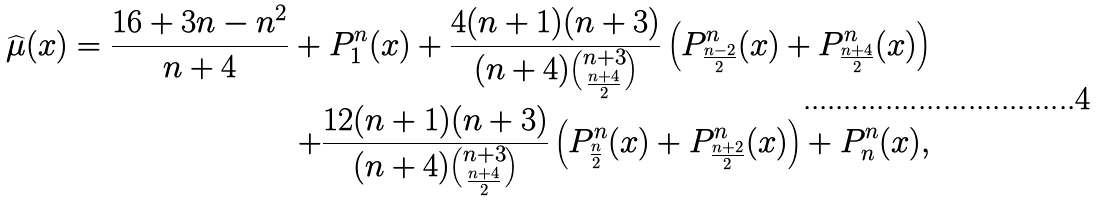Convert formula to latex. <formula><loc_0><loc_0><loc_500><loc_500>\widehat { \mu } ( x ) = \frac { 1 6 + 3 n - n ^ { 2 } } { n + 4 } + P _ { 1 } ^ { n } ( x ) + \frac { 4 ( n + 1 ) ( n + 3 ) } { ( n + 4 ) \binom { n + 3 } { \frac { n + 4 } { 2 } } } \left ( P _ { \frac { n - 2 } { 2 } } ^ { n } ( x ) + P _ { \frac { n + 4 } { 2 } } ^ { n } ( x ) \right ) \\ + \frac { 1 2 ( n + 1 ) ( n + 3 ) } { ( n + 4 ) \binom { n + 3 } { \frac { n + 4 } { 2 } } } \left ( P _ { \frac { n } { 2 } } ^ { n } ( x ) + P _ { \frac { n + 2 } { 2 } } ^ { n } ( x ) \right ) + P _ { n } ^ { n } ( x ) ,</formula> 